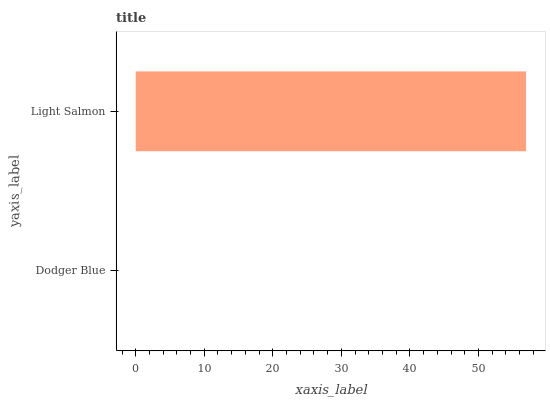Is Dodger Blue the minimum?
Answer yes or no. Yes. Is Light Salmon the maximum?
Answer yes or no. Yes. Is Light Salmon the minimum?
Answer yes or no. No. Is Light Salmon greater than Dodger Blue?
Answer yes or no. Yes. Is Dodger Blue less than Light Salmon?
Answer yes or no. Yes. Is Dodger Blue greater than Light Salmon?
Answer yes or no. No. Is Light Salmon less than Dodger Blue?
Answer yes or no. No. Is Light Salmon the high median?
Answer yes or no. Yes. Is Dodger Blue the low median?
Answer yes or no. Yes. Is Dodger Blue the high median?
Answer yes or no. No. Is Light Salmon the low median?
Answer yes or no. No. 